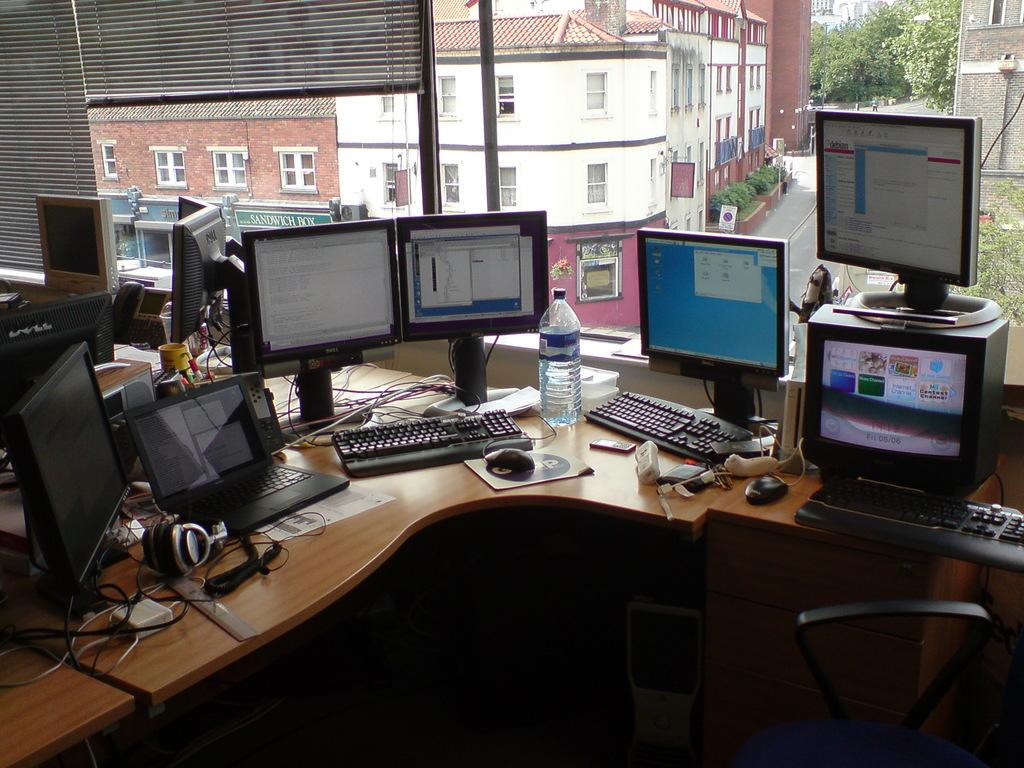What is the main piece of furniture in the image? There is a table in the image. What electronic devices are on the table? There are computers on the table. What can be seen on the table besides the computers? There is a water bottle and cables visible on the table. What is visible through the window in the image? Buildings and trees are visible through the window. What month is it in the image? The month cannot be determined from the image, as there is no information about the time of year. Is there any glue visible on the table? There is no glue present in the image. 